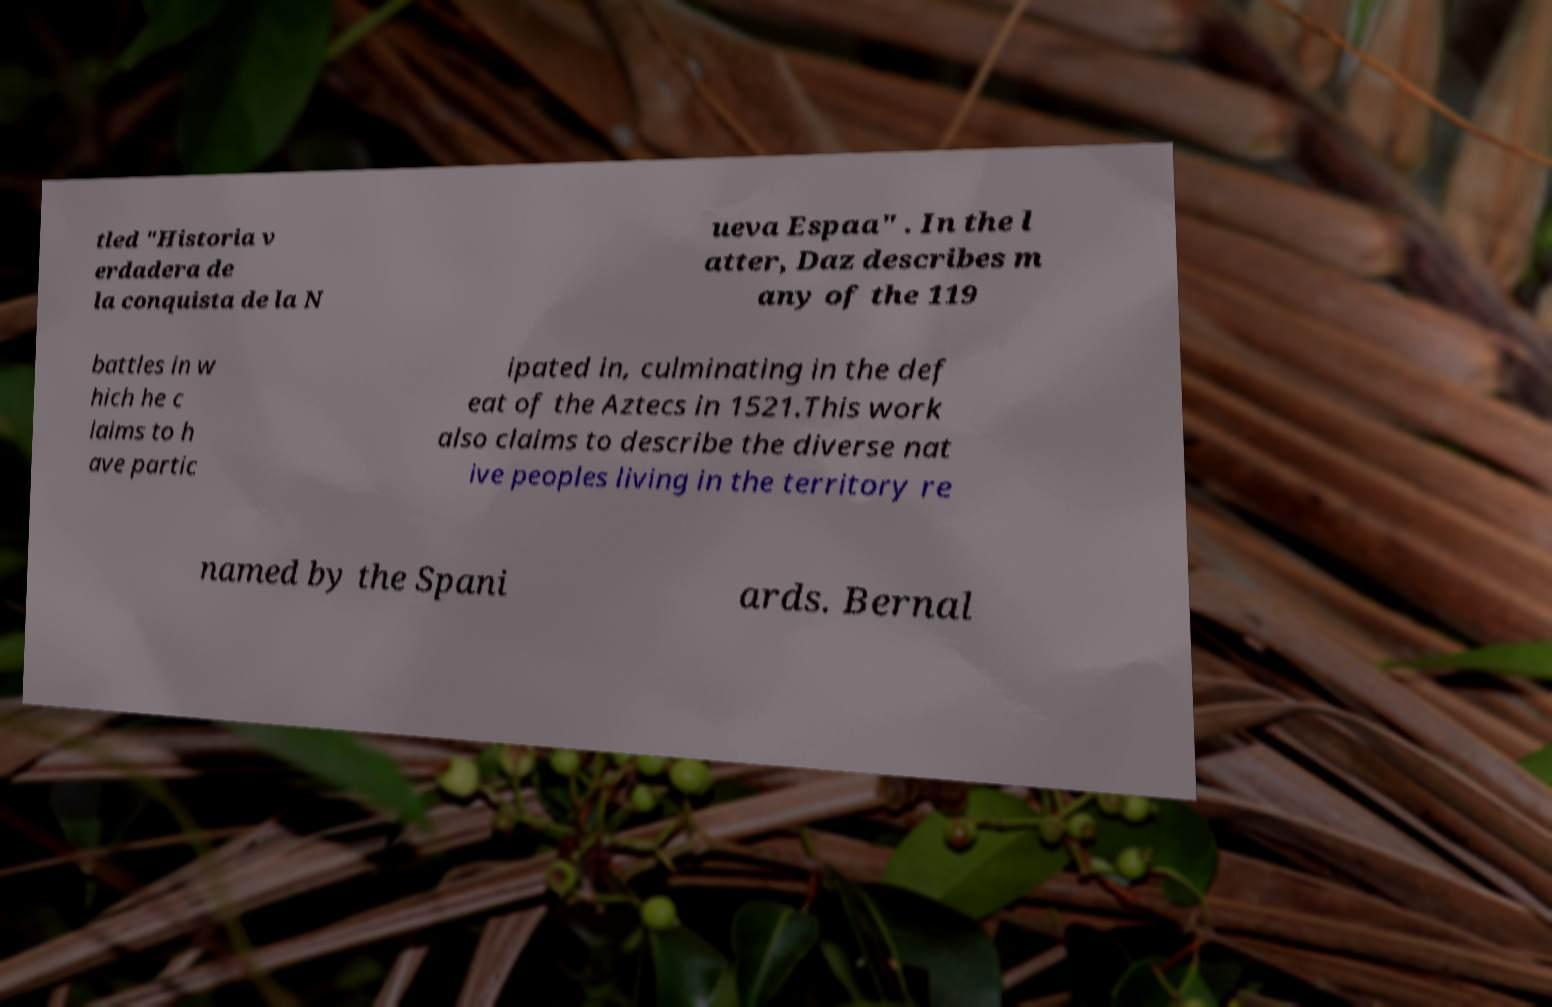Can you accurately transcribe the text from the provided image for me? tled "Historia v erdadera de la conquista de la N ueva Espaa" . In the l atter, Daz describes m any of the 119 battles in w hich he c laims to h ave partic ipated in, culminating in the def eat of the Aztecs in 1521.This work also claims to describe the diverse nat ive peoples living in the territory re named by the Spani ards. Bernal 